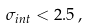Convert formula to latex. <formula><loc_0><loc_0><loc_500><loc_500>\sigma _ { i n t } < 2 . 5 \, ,</formula> 